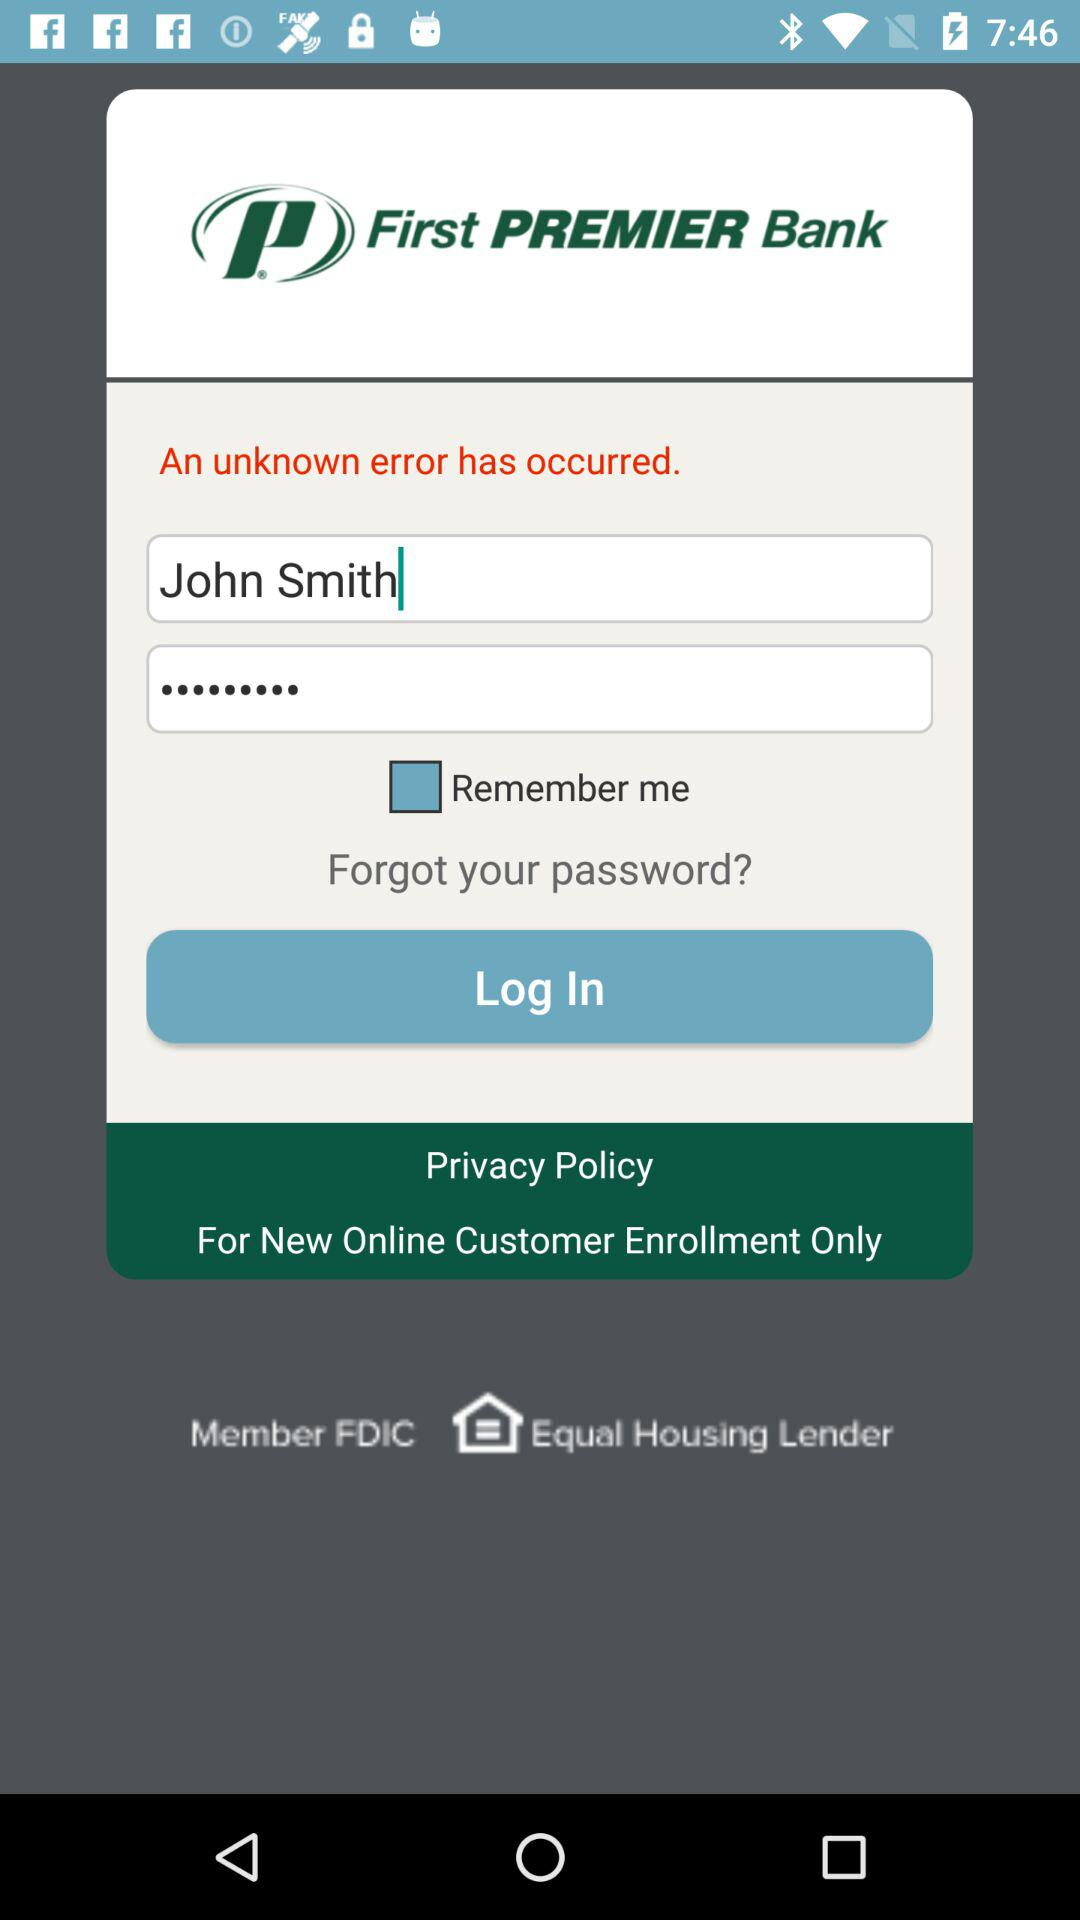What is the given user name? The given user name is John Smith. 